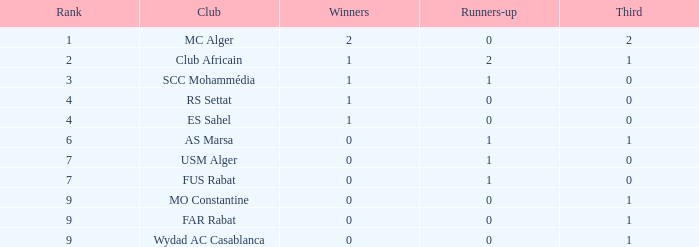How many champions possess a third of 1, and second-place finishers less than 0? 0.0. 